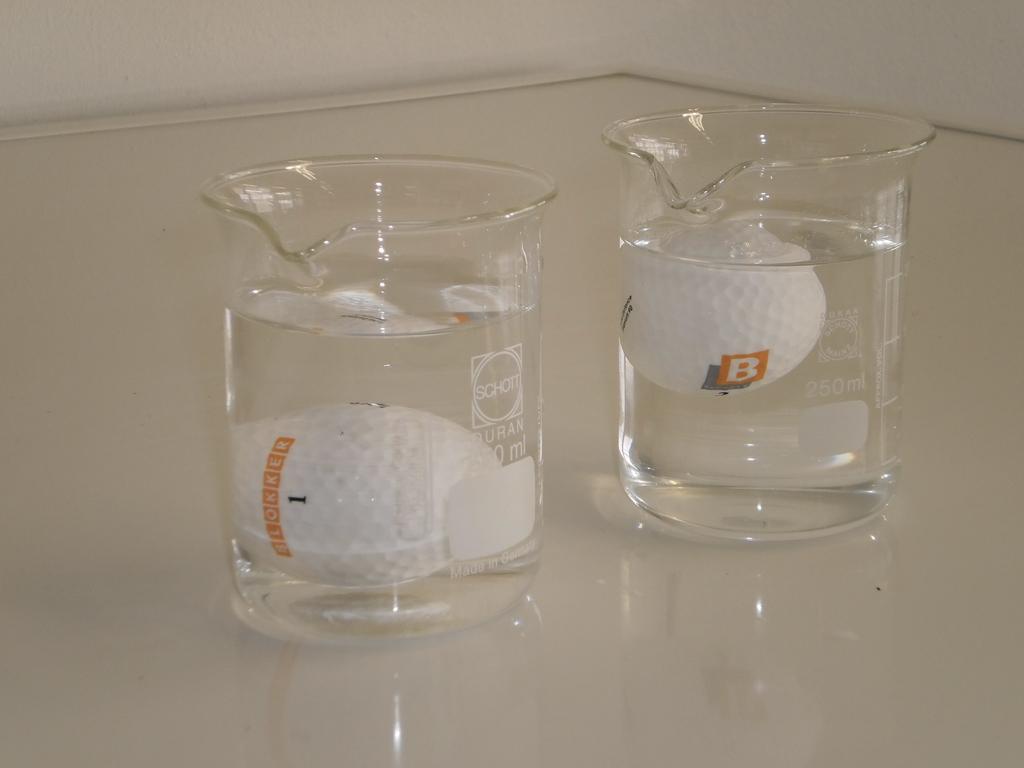What letter is on the ball in the glass on the right?
Provide a short and direct response. B. 